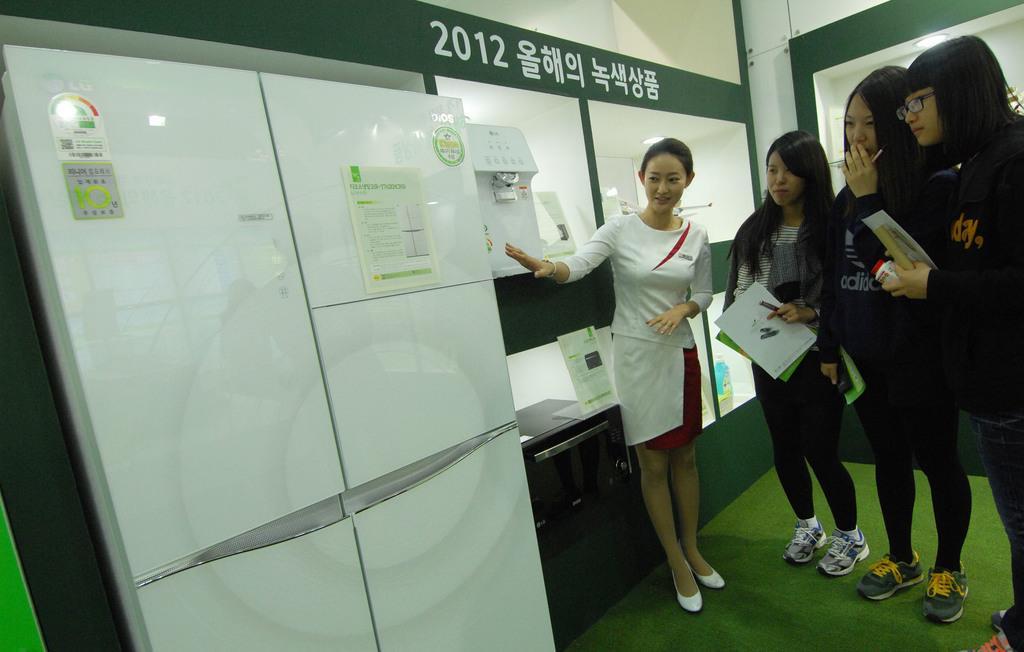Describe this image in one or two sentences. Here in this picture we can see a group of men standing on the floor and we can see some people are holding books in their hands and in front of them we can see a refrigerator present, as we can see a woman is explaining about that and we can also see a microwave Owen present in the rack and other electronic items also present in racks and we can see lights also present. 